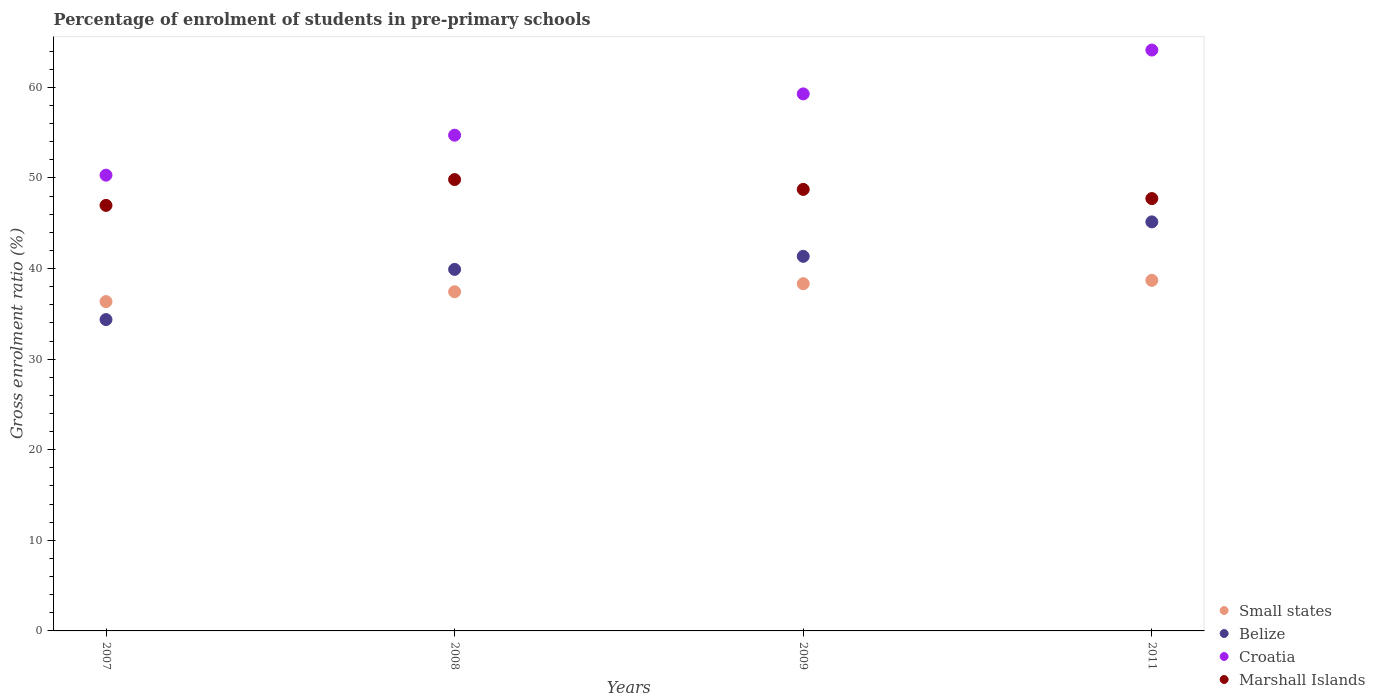What is the percentage of students enrolled in pre-primary schools in Croatia in 2009?
Your response must be concise. 59.28. Across all years, what is the maximum percentage of students enrolled in pre-primary schools in Belize?
Make the answer very short. 45.15. Across all years, what is the minimum percentage of students enrolled in pre-primary schools in Marshall Islands?
Ensure brevity in your answer.  46.97. In which year was the percentage of students enrolled in pre-primary schools in Croatia maximum?
Offer a very short reply. 2011. What is the total percentage of students enrolled in pre-primary schools in Marshall Islands in the graph?
Your answer should be very brief. 193.26. What is the difference between the percentage of students enrolled in pre-primary schools in Small states in 2007 and that in 2011?
Keep it short and to the point. -2.34. What is the difference between the percentage of students enrolled in pre-primary schools in Small states in 2011 and the percentage of students enrolled in pre-primary schools in Croatia in 2009?
Give a very brief answer. -20.58. What is the average percentage of students enrolled in pre-primary schools in Belize per year?
Your answer should be very brief. 40.19. In the year 2011, what is the difference between the percentage of students enrolled in pre-primary schools in Belize and percentage of students enrolled in pre-primary schools in Small states?
Provide a succinct answer. 6.46. In how many years, is the percentage of students enrolled in pre-primary schools in Belize greater than 30 %?
Provide a short and direct response. 4. What is the ratio of the percentage of students enrolled in pre-primary schools in Marshall Islands in 2007 to that in 2011?
Your answer should be compact. 0.98. Is the percentage of students enrolled in pre-primary schools in Croatia in 2007 less than that in 2011?
Provide a short and direct response. Yes. What is the difference between the highest and the second highest percentage of students enrolled in pre-primary schools in Croatia?
Ensure brevity in your answer.  4.84. What is the difference between the highest and the lowest percentage of students enrolled in pre-primary schools in Croatia?
Give a very brief answer. 13.81. Is the sum of the percentage of students enrolled in pre-primary schools in Marshall Islands in 2007 and 2009 greater than the maximum percentage of students enrolled in pre-primary schools in Small states across all years?
Your answer should be very brief. Yes. Is it the case that in every year, the sum of the percentage of students enrolled in pre-primary schools in Belize and percentage of students enrolled in pre-primary schools in Small states  is greater than the sum of percentage of students enrolled in pre-primary schools in Croatia and percentage of students enrolled in pre-primary schools in Marshall Islands?
Offer a terse response. No. Is the percentage of students enrolled in pre-primary schools in Small states strictly less than the percentage of students enrolled in pre-primary schools in Marshall Islands over the years?
Your response must be concise. Yes. How many dotlines are there?
Keep it short and to the point. 4. Does the graph contain grids?
Ensure brevity in your answer.  No. How many legend labels are there?
Offer a very short reply. 4. How are the legend labels stacked?
Provide a short and direct response. Vertical. What is the title of the graph?
Provide a succinct answer. Percentage of enrolment of students in pre-primary schools. Does "China" appear as one of the legend labels in the graph?
Provide a succinct answer. No. What is the label or title of the Y-axis?
Your answer should be very brief. Gross enrolment ratio (%). What is the Gross enrolment ratio (%) of Small states in 2007?
Your response must be concise. 36.35. What is the Gross enrolment ratio (%) in Belize in 2007?
Your response must be concise. 34.37. What is the Gross enrolment ratio (%) of Croatia in 2007?
Ensure brevity in your answer.  50.31. What is the Gross enrolment ratio (%) of Marshall Islands in 2007?
Keep it short and to the point. 46.97. What is the Gross enrolment ratio (%) of Small states in 2008?
Offer a terse response. 37.44. What is the Gross enrolment ratio (%) in Belize in 2008?
Keep it short and to the point. 39.91. What is the Gross enrolment ratio (%) of Croatia in 2008?
Offer a very short reply. 54.72. What is the Gross enrolment ratio (%) in Marshall Islands in 2008?
Provide a succinct answer. 49.82. What is the Gross enrolment ratio (%) in Small states in 2009?
Your answer should be compact. 38.33. What is the Gross enrolment ratio (%) of Belize in 2009?
Give a very brief answer. 41.35. What is the Gross enrolment ratio (%) of Croatia in 2009?
Your response must be concise. 59.28. What is the Gross enrolment ratio (%) of Marshall Islands in 2009?
Ensure brevity in your answer.  48.74. What is the Gross enrolment ratio (%) of Small states in 2011?
Give a very brief answer. 38.7. What is the Gross enrolment ratio (%) of Belize in 2011?
Your answer should be very brief. 45.15. What is the Gross enrolment ratio (%) of Croatia in 2011?
Your response must be concise. 64.12. What is the Gross enrolment ratio (%) of Marshall Islands in 2011?
Give a very brief answer. 47.73. Across all years, what is the maximum Gross enrolment ratio (%) of Small states?
Give a very brief answer. 38.7. Across all years, what is the maximum Gross enrolment ratio (%) in Belize?
Provide a succinct answer. 45.15. Across all years, what is the maximum Gross enrolment ratio (%) of Croatia?
Your response must be concise. 64.12. Across all years, what is the maximum Gross enrolment ratio (%) of Marshall Islands?
Offer a very short reply. 49.82. Across all years, what is the minimum Gross enrolment ratio (%) in Small states?
Your answer should be compact. 36.35. Across all years, what is the minimum Gross enrolment ratio (%) of Belize?
Your answer should be very brief. 34.37. Across all years, what is the minimum Gross enrolment ratio (%) of Croatia?
Offer a terse response. 50.31. Across all years, what is the minimum Gross enrolment ratio (%) of Marshall Islands?
Provide a succinct answer. 46.97. What is the total Gross enrolment ratio (%) in Small states in the graph?
Your answer should be very brief. 150.82. What is the total Gross enrolment ratio (%) of Belize in the graph?
Provide a succinct answer. 160.78. What is the total Gross enrolment ratio (%) in Croatia in the graph?
Make the answer very short. 228.43. What is the total Gross enrolment ratio (%) of Marshall Islands in the graph?
Provide a succinct answer. 193.26. What is the difference between the Gross enrolment ratio (%) of Small states in 2007 and that in 2008?
Provide a succinct answer. -1.09. What is the difference between the Gross enrolment ratio (%) of Belize in 2007 and that in 2008?
Your response must be concise. -5.54. What is the difference between the Gross enrolment ratio (%) of Croatia in 2007 and that in 2008?
Give a very brief answer. -4.41. What is the difference between the Gross enrolment ratio (%) of Marshall Islands in 2007 and that in 2008?
Give a very brief answer. -2.85. What is the difference between the Gross enrolment ratio (%) in Small states in 2007 and that in 2009?
Give a very brief answer. -1.97. What is the difference between the Gross enrolment ratio (%) in Belize in 2007 and that in 2009?
Offer a terse response. -6.98. What is the difference between the Gross enrolment ratio (%) of Croatia in 2007 and that in 2009?
Offer a terse response. -8.97. What is the difference between the Gross enrolment ratio (%) of Marshall Islands in 2007 and that in 2009?
Your answer should be very brief. -1.76. What is the difference between the Gross enrolment ratio (%) of Small states in 2007 and that in 2011?
Keep it short and to the point. -2.34. What is the difference between the Gross enrolment ratio (%) of Belize in 2007 and that in 2011?
Give a very brief answer. -10.78. What is the difference between the Gross enrolment ratio (%) in Croatia in 2007 and that in 2011?
Ensure brevity in your answer.  -13.81. What is the difference between the Gross enrolment ratio (%) of Marshall Islands in 2007 and that in 2011?
Give a very brief answer. -0.75. What is the difference between the Gross enrolment ratio (%) of Small states in 2008 and that in 2009?
Ensure brevity in your answer.  -0.89. What is the difference between the Gross enrolment ratio (%) of Belize in 2008 and that in 2009?
Provide a short and direct response. -1.44. What is the difference between the Gross enrolment ratio (%) of Croatia in 2008 and that in 2009?
Provide a succinct answer. -4.56. What is the difference between the Gross enrolment ratio (%) in Marshall Islands in 2008 and that in 2009?
Your answer should be compact. 1.09. What is the difference between the Gross enrolment ratio (%) of Small states in 2008 and that in 2011?
Ensure brevity in your answer.  -1.26. What is the difference between the Gross enrolment ratio (%) in Belize in 2008 and that in 2011?
Ensure brevity in your answer.  -5.24. What is the difference between the Gross enrolment ratio (%) of Croatia in 2008 and that in 2011?
Give a very brief answer. -9.4. What is the difference between the Gross enrolment ratio (%) of Marshall Islands in 2008 and that in 2011?
Your answer should be compact. 2.1. What is the difference between the Gross enrolment ratio (%) of Small states in 2009 and that in 2011?
Make the answer very short. -0.37. What is the difference between the Gross enrolment ratio (%) of Belize in 2009 and that in 2011?
Offer a terse response. -3.8. What is the difference between the Gross enrolment ratio (%) of Croatia in 2009 and that in 2011?
Provide a short and direct response. -4.84. What is the difference between the Gross enrolment ratio (%) in Small states in 2007 and the Gross enrolment ratio (%) in Belize in 2008?
Provide a short and direct response. -3.55. What is the difference between the Gross enrolment ratio (%) in Small states in 2007 and the Gross enrolment ratio (%) in Croatia in 2008?
Your answer should be compact. -18.37. What is the difference between the Gross enrolment ratio (%) in Small states in 2007 and the Gross enrolment ratio (%) in Marshall Islands in 2008?
Provide a short and direct response. -13.47. What is the difference between the Gross enrolment ratio (%) of Belize in 2007 and the Gross enrolment ratio (%) of Croatia in 2008?
Your response must be concise. -20.35. What is the difference between the Gross enrolment ratio (%) in Belize in 2007 and the Gross enrolment ratio (%) in Marshall Islands in 2008?
Make the answer very short. -15.46. What is the difference between the Gross enrolment ratio (%) in Croatia in 2007 and the Gross enrolment ratio (%) in Marshall Islands in 2008?
Your response must be concise. 0.49. What is the difference between the Gross enrolment ratio (%) in Small states in 2007 and the Gross enrolment ratio (%) in Belize in 2009?
Your answer should be very brief. -4.99. What is the difference between the Gross enrolment ratio (%) in Small states in 2007 and the Gross enrolment ratio (%) in Croatia in 2009?
Offer a terse response. -22.93. What is the difference between the Gross enrolment ratio (%) in Small states in 2007 and the Gross enrolment ratio (%) in Marshall Islands in 2009?
Ensure brevity in your answer.  -12.38. What is the difference between the Gross enrolment ratio (%) of Belize in 2007 and the Gross enrolment ratio (%) of Croatia in 2009?
Your answer should be compact. -24.91. What is the difference between the Gross enrolment ratio (%) in Belize in 2007 and the Gross enrolment ratio (%) in Marshall Islands in 2009?
Your answer should be compact. -14.37. What is the difference between the Gross enrolment ratio (%) in Croatia in 2007 and the Gross enrolment ratio (%) in Marshall Islands in 2009?
Offer a terse response. 1.57. What is the difference between the Gross enrolment ratio (%) in Small states in 2007 and the Gross enrolment ratio (%) in Belize in 2011?
Your response must be concise. -8.8. What is the difference between the Gross enrolment ratio (%) in Small states in 2007 and the Gross enrolment ratio (%) in Croatia in 2011?
Keep it short and to the point. -27.77. What is the difference between the Gross enrolment ratio (%) of Small states in 2007 and the Gross enrolment ratio (%) of Marshall Islands in 2011?
Provide a short and direct response. -11.37. What is the difference between the Gross enrolment ratio (%) of Belize in 2007 and the Gross enrolment ratio (%) of Croatia in 2011?
Provide a succinct answer. -29.75. What is the difference between the Gross enrolment ratio (%) of Belize in 2007 and the Gross enrolment ratio (%) of Marshall Islands in 2011?
Keep it short and to the point. -13.36. What is the difference between the Gross enrolment ratio (%) of Croatia in 2007 and the Gross enrolment ratio (%) of Marshall Islands in 2011?
Your response must be concise. 2.58. What is the difference between the Gross enrolment ratio (%) of Small states in 2008 and the Gross enrolment ratio (%) of Belize in 2009?
Offer a terse response. -3.91. What is the difference between the Gross enrolment ratio (%) in Small states in 2008 and the Gross enrolment ratio (%) in Croatia in 2009?
Ensure brevity in your answer.  -21.84. What is the difference between the Gross enrolment ratio (%) of Small states in 2008 and the Gross enrolment ratio (%) of Marshall Islands in 2009?
Make the answer very short. -11.3. What is the difference between the Gross enrolment ratio (%) of Belize in 2008 and the Gross enrolment ratio (%) of Croatia in 2009?
Provide a short and direct response. -19.37. What is the difference between the Gross enrolment ratio (%) in Belize in 2008 and the Gross enrolment ratio (%) in Marshall Islands in 2009?
Keep it short and to the point. -8.83. What is the difference between the Gross enrolment ratio (%) of Croatia in 2008 and the Gross enrolment ratio (%) of Marshall Islands in 2009?
Offer a very short reply. 5.98. What is the difference between the Gross enrolment ratio (%) of Small states in 2008 and the Gross enrolment ratio (%) of Belize in 2011?
Offer a very short reply. -7.71. What is the difference between the Gross enrolment ratio (%) in Small states in 2008 and the Gross enrolment ratio (%) in Croatia in 2011?
Offer a terse response. -26.68. What is the difference between the Gross enrolment ratio (%) in Small states in 2008 and the Gross enrolment ratio (%) in Marshall Islands in 2011?
Your answer should be very brief. -10.29. What is the difference between the Gross enrolment ratio (%) of Belize in 2008 and the Gross enrolment ratio (%) of Croatia in 2011?
Ensure brevity in your answer.  -24.21. What is the difference between the Gross enrolment ratio (%) of Belize in 2008 and the Gross enrolment ratio (%) of Marshall Islands in 2011?
Offer a very short reply. -7.82. What is the difference between the Gross enrolment ratio (%) in Croatia in 2008 and the Gross enrolment ratio (%) in Marshall Islands in 2011?
Your answer should be very brief. 7. What is the difference between the Gross enrolment ratio (%) of Small states in 2009 and the Gross enrolment ratio (%) of Belize in 2011?
Provide a short and direct response. -6.82. What is the difference between the Gross enrolment ratio (%) of Small states in 2009 and the Gross enrolment ratio (%) of Croatia in 2011?
Provide a short and direct response. -25.79. What is the difference between the Gross enrolment ratio (%) of Small states in 2009 and the Gross enrolment ratio (%) of Marshall Islands in 2011?
Ensure brevity in your answer.  -9.4. What is the difference between the Gross enrolment ratio (%) of Belize in 2009 and the Gross enrolment ratio (%) of Croatia in 2011?
Provide a short and direct response. -22.77. What is the difference between the Gross enrolment ratio (%) in Belize in 2009 and the Gross enrolment ratio (%) in Marshall Islands in 2011?
Provide a short and direct response. -6.38. What is the difference between the Gross enrolment ratio (%) of Croatia in 2009 and the Gross enrolment ratio (%) of Marshall Islands in 2011?
Provide a short and direct response. 11.55. What is the average Gross enrolment ratio (%) in Small states per year?
Your answer should be compact. 37.7. What is the average Gross enrolment ratio (%) of Belize per year?
Keep it short and to the point. 40.19. What is the average Gross enrolment ratio (%) in Croatia per year?
Your response must be concise. 57.11. What is the average Gross enrolment ratio (%) in Marshall Islands per year?
Your answer should be compact. 48.31. In the year 2007, what is the difference between the Gross enrolment ratio (%) of Small states and Gross enrolment ratio (%) of Belize?
Offer a very short reply. 1.99. In the year 2007, what is the difference between the Gross enrolment ratio (%) of Small states and Gross enrolment ratio (%) of Croatia?
Make the answer very short. -13.96. In the year 2007, what is the difference between the Gross enrolment ratio (%) of Small states and Gross enrolment ratio (%) of Marshall Islands?
Provide a succinct answer. -10.62. In the year 2007, what is the difference between the Gross enrolment ratio (%) of Belize and Gross enrolment ratio (%) of Croatia?
Provide a succinct answer. -15.94. In the year 2007, what is the difference between the Gross enrolment ratio (%) of Belize and Gross enrolment ratio (%) of Marshall Islands?
Make the answer very short. -12.6. In the year 2007, what is the difference between the Gross enrolment ratio (%) in Croatia and Gross enrolment ratio (%) in Marshall Islands?
Keep it short and to the point. 3.34. In the year 2008, what is the difference between the Gross enrolment ratio (%) in Small states and Gross enrolment ratio (%) in Belize?
Offer a terse response. -2.47. In the year 2008, what is the difference between the Gross enrolment ratio (%) of Small states and Gross enrolment ratio (%) of Croatia?
Make the answer very short. -17.28. In the year 2008, what is the difference between the Gross enrolment ratio (%) of Small states and Gross enrolment ratio (%) of Marshall Islands?
Your answer should be compact. -12.38. In the year 2008, what is the difference between the Gross enrolment ratio (%) in Belize and Gross enrolment ratio (%) in Croatia?
Your answer should be very brief. -14.81. In the year 2008, what is the difference between the Gross enrolment ratio (%) in Belize and Gross enrolment ratio (%) in Marshall Islands?
Keep it short and to the point. -9.92. In the year 2008, what is the difference between the Gross enrolment ratio (%) in Croatia and Gross enrolment ratio (%) in Marshall Islands?
Keep it short and to the point. 4.9. In the year 2009, what is the difference between the Gross enrolment ratio (%) in Small states and Gross enrolment ratio (%) in Belize?
Provide a succinct answer. -3.02. In the year 2009, what is the difference between the Gross enrolment ratio (%) in Small states and Gross enrolment ratio (%) in Croatia?
Give a very brief answer. -20.95. In the year 2009, what is the difference between the Gross enrolment ratio (%) of Small states and Gross enrolment ratio (%) of Marshall Islands?
Keep it short and to the point. -10.41. In the year 2009, what is the difference between the Gross enrolment ratio (%) of Belize and Gross enrolment ratio (%) of Croatia?
Keep it short and to the point. -17.93. In the year 2009, what is the difference between the Gross enrolment ratio (%) of Belize and Gross enrolment ratio (%) of Marshall Islands?
Your response must be concise. -7.39. In the year 2009, what is the difference between the Gross enrolment ratio (%) in Croatia and Gross enrolment ratio (%) in Marshall Islands?
Your response must be concise. 10.54. In the year 2011, what is the difference between the Gross enrolment ratio (%) in Small states and Gross enrolment ratio (%) in Belize?
Provide a short and direct response. -6.46. In the year 2011, what is the difference between the Gross enrolment ratio (%) in Small states and Gross enrolment ratio (%) in Croatia?
Keep it short and to the point. -25.42. In the year 2011, what is the difference between the Gross enrolment ratio (%) of Small states and Gross enrolment ratio (%) of Marshall Islands?
Your response must be concise. -9.03. In the year 2011, what is the difference between the Gross enrolment ratio (%) in Belize and Gross enrolment ratio (%) in Croatia?
Offer a terse response. -18.97. In the year 2011, what is the difference between the Gross enrolment ratio (%) in Belize and Gross enrolment ratio (%) in Marshall Islands?
Offer a very short reply. -2.57. In the year 2011, what is the difference between the Gross enrolment ratio (%) of Croatia and Gross enrolment ratio (%) of Marshall Islands?
Offer a very short reply. 16.39. What is the ratio of the Gross enrolment ratio (%) in Belize in 2007 to that in 2008?
Give a very brief answer. 0.86. What is the ratio of the Gross enrolment ratio (%) of Croatia in 2007 to that in 2008?
Offer a terse response. 0.92. What is the ratio of the Gross enrolment ratio (%) of Marshall Islands in 2007 to that in 2008?
Offer a terse response. 0.94. What is the ratio of the Gross enrolment ratio (%) of Small states in 2007 to that in 2009?
Ensure brevity in your answer.  0.95. What is the ratio of the Gross enrolment ratio (%) in Belize in 2007 to that in 2009?
Keep it short and to the point. 0.83. What is the ratio of the Gross enrolment ratio (%) in Croatia in 2007 to that in 2009?
Provide a succinct answer. 0.85. What is the ratio of the Gross enrolment ratio (%) of Marshall Islands in 2007 to that in 2009?
Provide a short and direct response. 0.96. What is the ratio of the Gross enrolment ratio (%) of Small states in 2007 to that in 2011?
Your answer should be very brief. 0.94. What is the ratio of the Gross enrolment ratio (%) of Belize in 2007 to that in 2011?
Your answer should be compact. 0.76. What is the ratio of the Gross enrolment ratio (%) in Croatia in 2007 to that in 2011?
Offer a terse response. 0.78. What is the ratio of the Gross enrolment ratio (%) of Marshall Islands in 2007 to that in 2011?
Your answer should be very brief. 0.98. What is the ratio of the Gross enrolment ratio (%) of Small states in 2008 to that in 2009?
Keep it short and to the point. 0.98. What is the ratio of the Gross enrolment ratio (%) of Belize in 2008 to that in 2009?
Provide a succinct answer. 0.97. What is the ratio of the Gross enrolment ratio (%) in Croatia in 2008 to that in 2009?
Give a very brief answer. 0.92. What is the ratio of the Gross enrolment ratio (%) in Marshall Islands in 2008 to that in 2009?
Your answer should be compact. 1.02. What is the ratio of the Gross enrolment ratio (%) in Small states in 2008 to that in 2011?
Offer a terse response. 0.97. What is the ratio of the Gross enrolment ratio (%) of Belize in 2008 to that in 2011?
Your answer should be very brief. 0.88. What is the ratio of the Gross enrolment ratio (%) in Croatia in 2008 to that in 2011?
Your answer should be very brief. 0.85. What is the ratio of the Gross enrolment ratio (%) of Marshall Islands in 2008 to that in 2011?
Offer a very short reply. 1.04. What is the ratio of the Gross enrolment ratio (%) of Small states in 2009 to that in 2011?
Your answer should be compact. 0.99. What is the ratio of the Gross enrolment ratio (%) of Belize in 2009 to that in 2011?
Give a very brief answer. 0.92. What is the ratio of the Gross enrolment ratio (%) of Croatia in 2009 to that in 2011?
Your response must be concise. 0.92. What is the ratio of the Gross enrolment ratio (%) of Marshall Islands in 2009 to that in 2011?
Offer a very short reply. 1.02. What is the difference between the highest and the second highest Gross enrolment ratio (%) of Small states?
Give a very brief answer. 0.37. What is the difference between the highest and the second highest Gross enrolment ratio (%) in Belize?
Offer a terse response. 3.8. What is the difference between the highest and the second highest Gross enrolment ratio (%) of Croatia?
Your answer should be compact. 4.84. What is the difference between the highest and the second highest Gross enrolment ratio (%) in Marshall Islands?
Offer a very short reply. 1.09. What is the difference between the highest and the lowest Gross enrolment ratio (%) of Small states?
Make the answer very short. 2.34. What is the difference between the highest and the lowest Gross enrolment ratio (%) of Belize?
Your answer should be very brief. 10.78. What is the difference between the highest and the lowest Gross enrolment ratio (%) in Croatia?
Offer a very short reply. 13.81. What is the difference between the highest and the lowest Gross enrolment ratio (%) of Marshall Islands?
Ensure brevity in your answer.  2.85. 